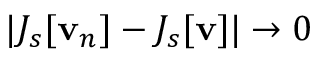Convert formula to latex. <formula><loc_0><loc_0><loc_500><loc_500>| J _ { s } [ v _ { n } ] - J _ { s } [ v ] | \to 0</formula> 